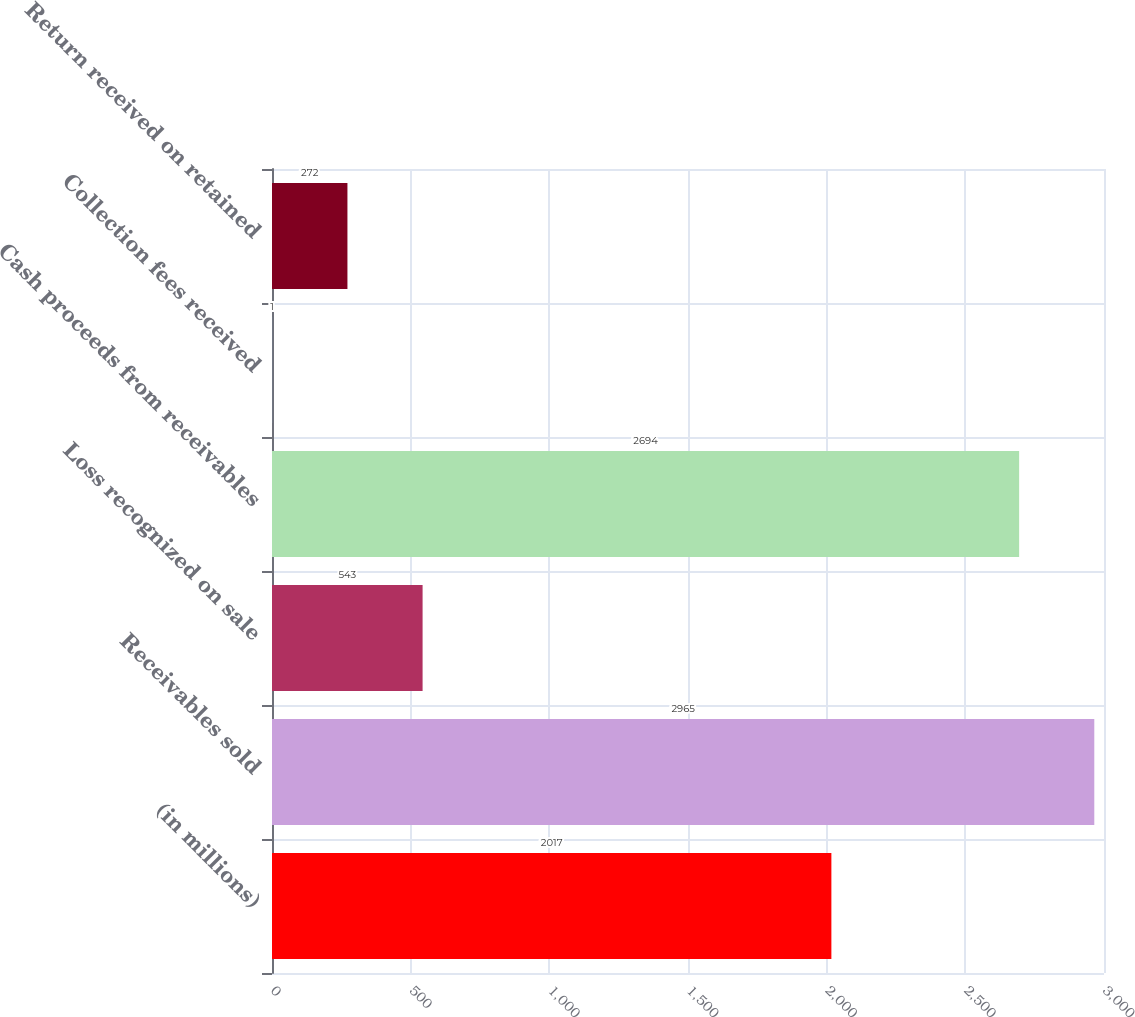Convert chart to OTSL. <chart><loc_0><loc_0><loc_500><loc_500><bar_chart><fcel>(in millions)<fcel>Receivables sold<fcel>Loss recognized on sale<fcel>Cash proceeds from receivables<fcel>Collection fees received<fcel>Return received on retained<nl><fcel>2017<fcel>2965<fcel>543<fcel>2694<fcel>1<fcel>272<nl></chart> 